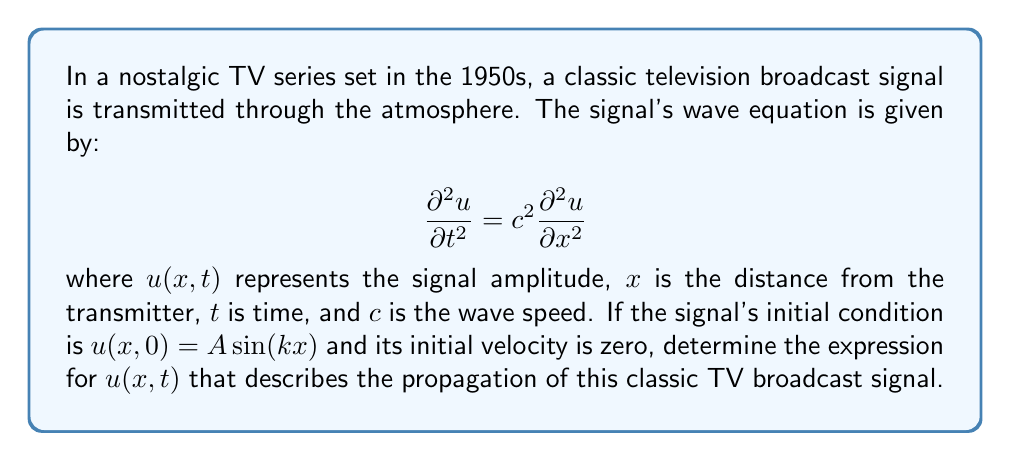Show me your answer to this math problem. To solve this problem, we'll follow these steps:

1) The general solution for the wave equation with the given initial conditions is of the form:

   $$u(x,t) = F(x-ct) + G(x+ct)$$

   where $F$ and $G$ are arbitrary functions.

2) Given the initial condition $u(x,0) = A \sin(kx)$, we can write:

   $$F(x) + G(x) = A \sin(kx)$$

3) The initial velocity condition $\frac{\partial u}{\partial t}(x,0) = 0$ implies:

   $$-cF'(x) + cG'(x) = 0$$

   or $F'(x) = G'(x)$

4) From steps 2 and 3, we can deduce:

   $$F(x) = G(x) = \frac{1}{2}A \sin(kx)$$

5) Substituting these into the general solution:

   $$u(x,t) = \frac{1}{2}A \sin(k(x-ct)) + \frac{1}{2}A \sin(k(x+ct))$$

6) Using the trigonometric identity for the sum of sines:

   $$\sin(a) + \sin(b) = 2 \sin(\frac{a+b}{2}) \cos(\frac{a-b}{2})$$

7) We get:

   $$u(x,t) = A \sin(kx) \cos(kct)$$

This expression represents a standing wave, which is the superposition of two waves traveling in opposite directions.
Answer: $u(x,t) = A \sin(kx) \cos(kct)$ 